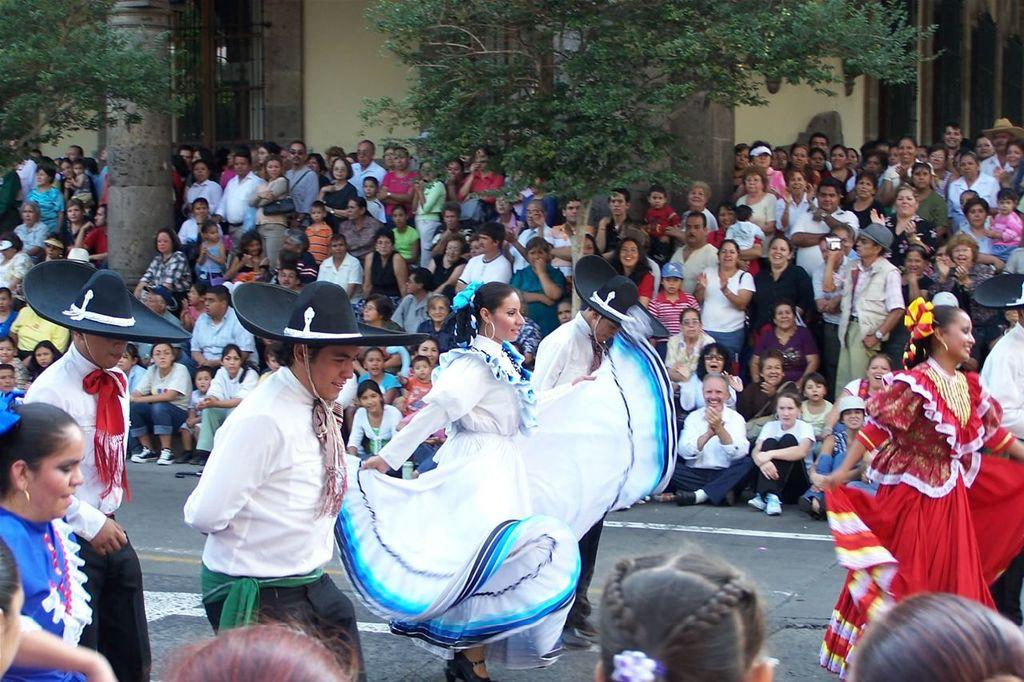Who or what can be seen in the image? There are people in the image. What is the primary feature of the landscape in the image? There is a road visible in the image. What type of natural environment is present in the background of the image? There are trees in the background of the image. What type of man-made structure is visible in the background of the image? There is a building in the background of the image. What type of rice is being served in the image? There is no rice present in the image. How many wings can be seen on the people in the image? The people in the image do not have wings; they are regular human beings. 